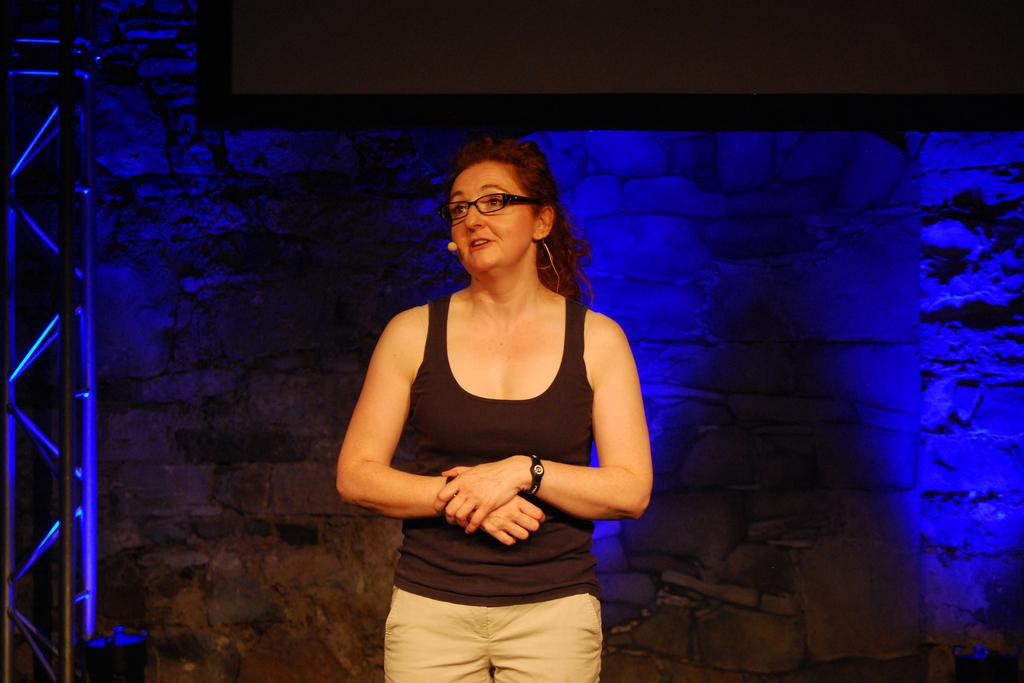Who is the main subject in the image? There is a woman standing in the center of the image. What is the woman standing on? The woman is standing on the floor. What can be seen in the background of the image? There is a wall and a screen in the background of the image. Reasoning: Let's think step by step by step in order to produce the conversation. We start by identifying the main subject in the image, which is the woman. Then, we describe her position and what she is standing on, which is the floor. Finally, we mention the background elements, including the wall and the screen. Each question is designed to elicit a specific detail about the image that is known from the provided facts. Absurd Question/Answer: What type of caption is written on the screen in the background? There is no caption visible on the screen in the image. Can you see any wrens flying around the woman in the image? There are no wrens present in the image. Is there any rain visible in the image? There is no rain visible in the image. What type of creature is interacting with the woman in the image? There are no creatures present in the image. 